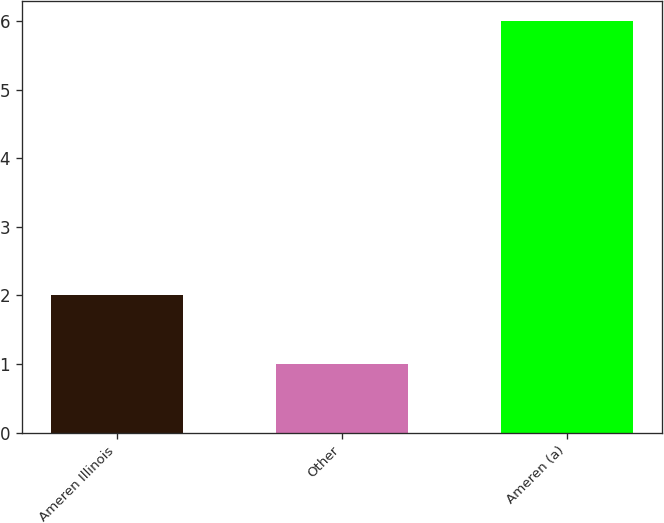Convert chart. <chart><loc_0><loc_0><loc_500><loc_500><bar_chart><fcel>Ameren Illinois<fcel>Other<fcel>Ameren (a)<nl><fcel>2<fcel>1<fcel>6<nl></chart> 